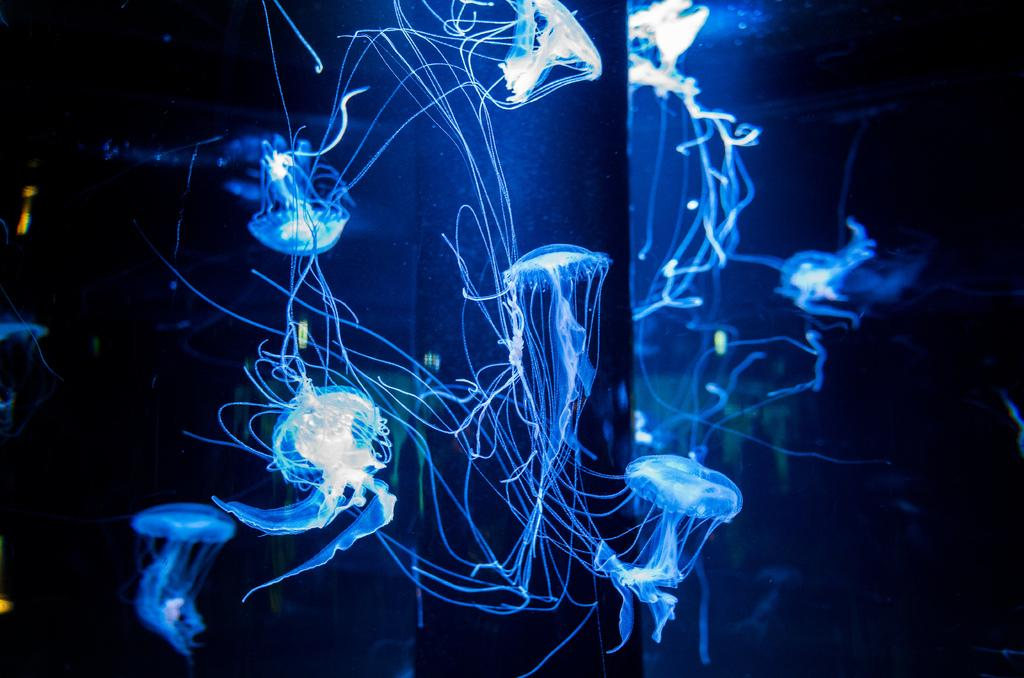What type of sea creatures are in the image? There are jellyfish in the image. Where are the jellyfish located? The jellyfish are in the water. How many steps does it take to reach the jellyfish in the image? There is no reference to steps or a physical location in the image, as it features jellyfish in the water. 